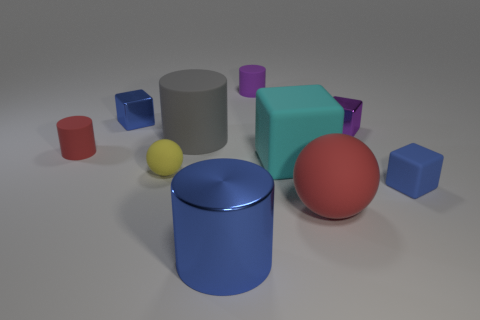How many blue blocks must be subtracted to get 1 blue blocks? 1 Subtract all cylinders. How many objects are left? 6 Add 2 red rubber things. How many red rubber things are left? 4 Add 8 blue cubes. How many blue cubes exist? 10 Subtract 1 purple cylinders. How many objects are left? 9 Subtract all purple matte cylinders. Subtract all red things. How many objects are left? 7 